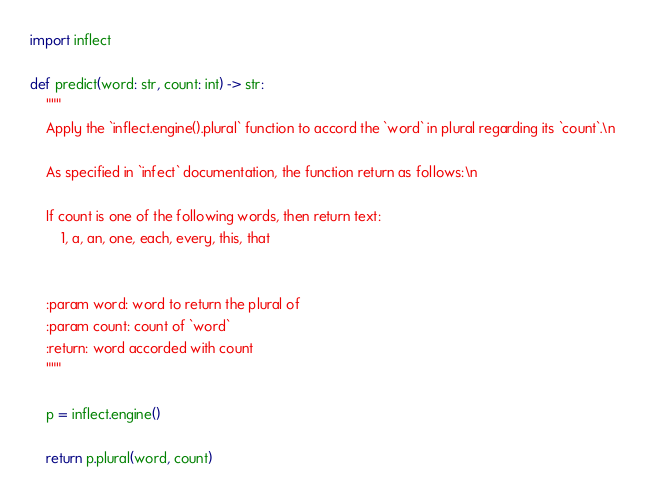Convert code to text. <code><loc_0><loc_0><loc_500><loc_500><_Python_>import inflect

def predict(word: str, count: int) -> str:
    """
    Apply the `inflect.engine().plural` function to accord the `word` in plural regarding its `count`.\n

    As specified in `infect` documentation, the function return as follows:\n

    If count is one of the following words, then return text:
        1, a, an, one, each, every, this, that


    :param word: word to return the plural of
    :param count: count of `word`
    :return: word accorded with count
    """

    p = inflect.engine()

    return p.plural(word, count)
</code> 